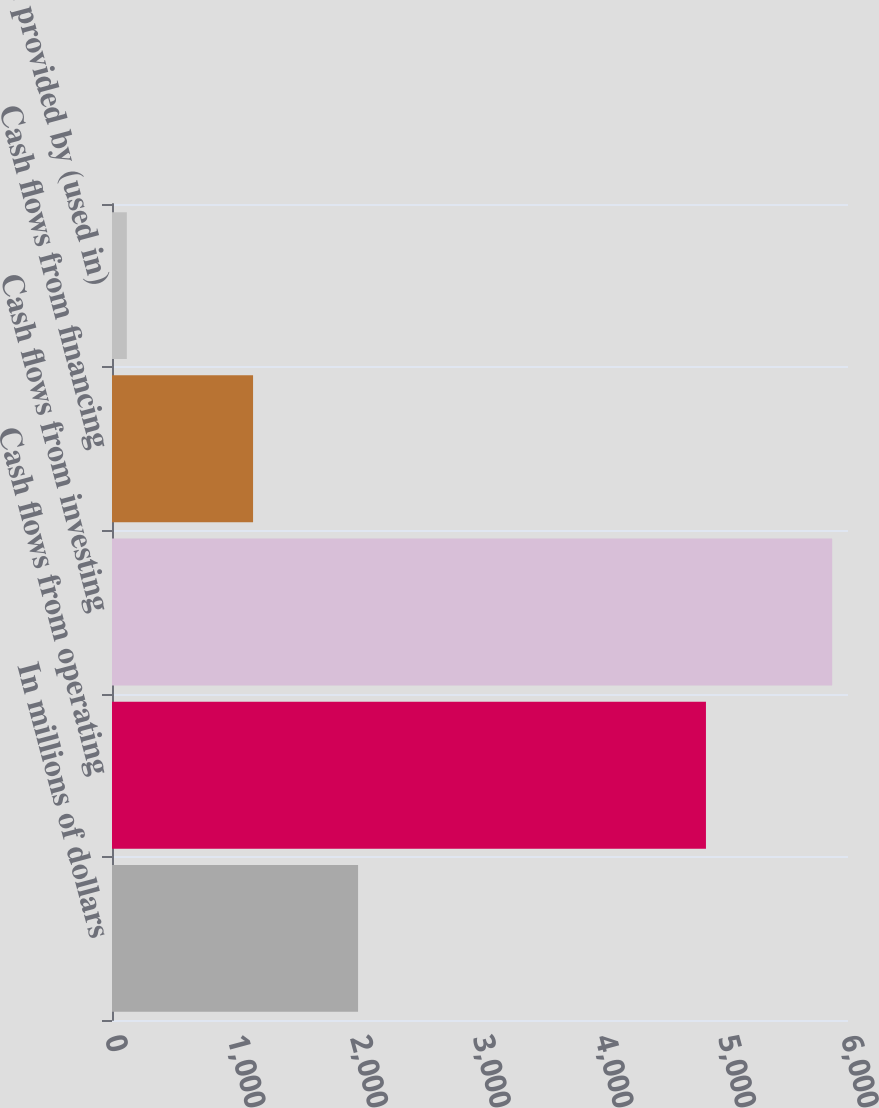Convert chart to OTSL. <chart><loc_0><loc_0><loc_500><loc_500><bar_chart><fcel>In millions of dollars<fcel>Cash flows from operating<fcel>Cash flows from investing<fcel>Cash flows from financing<fcel>Net cash provided by (used in)<nl><fcel>2006<fcel>4842<fcel>5871<fcel>1150<fcel>121<nl></chart> 